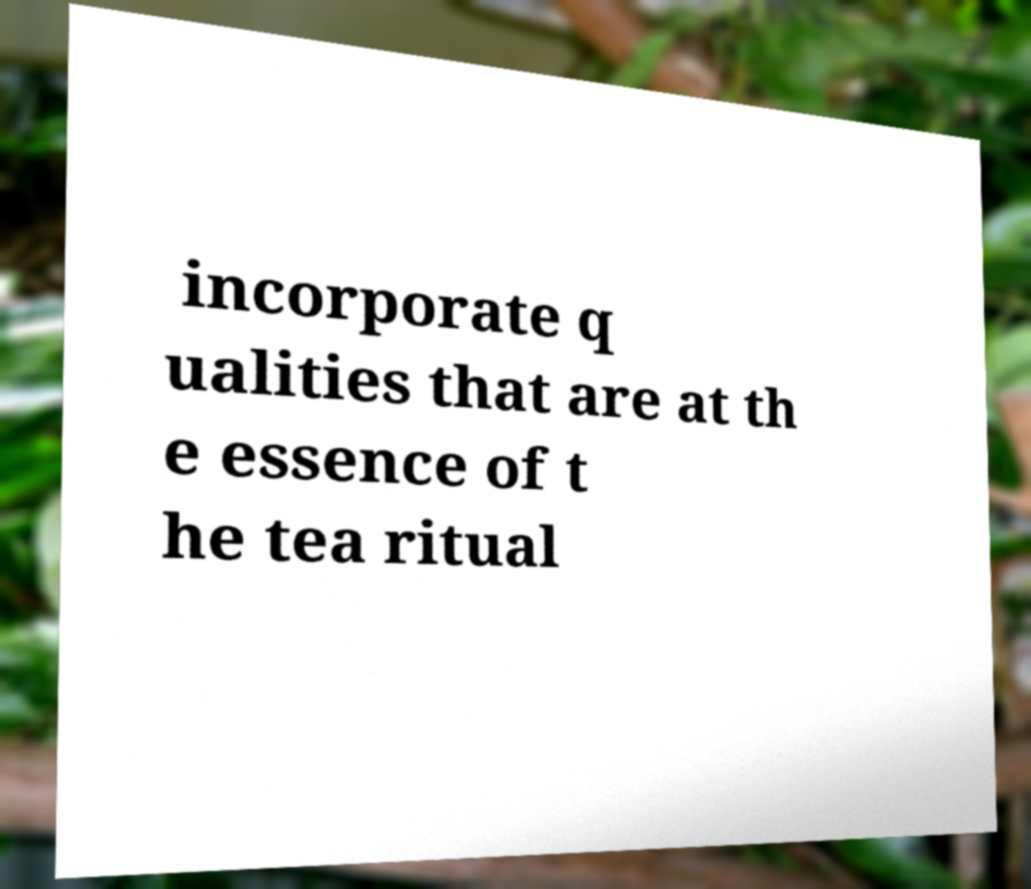Can you read and provide the text displayed in the image?This photo seems to have some interesting text. Can you extract and type it out for me? incorporate q ualities that are at th e essence of t he tea ritual 